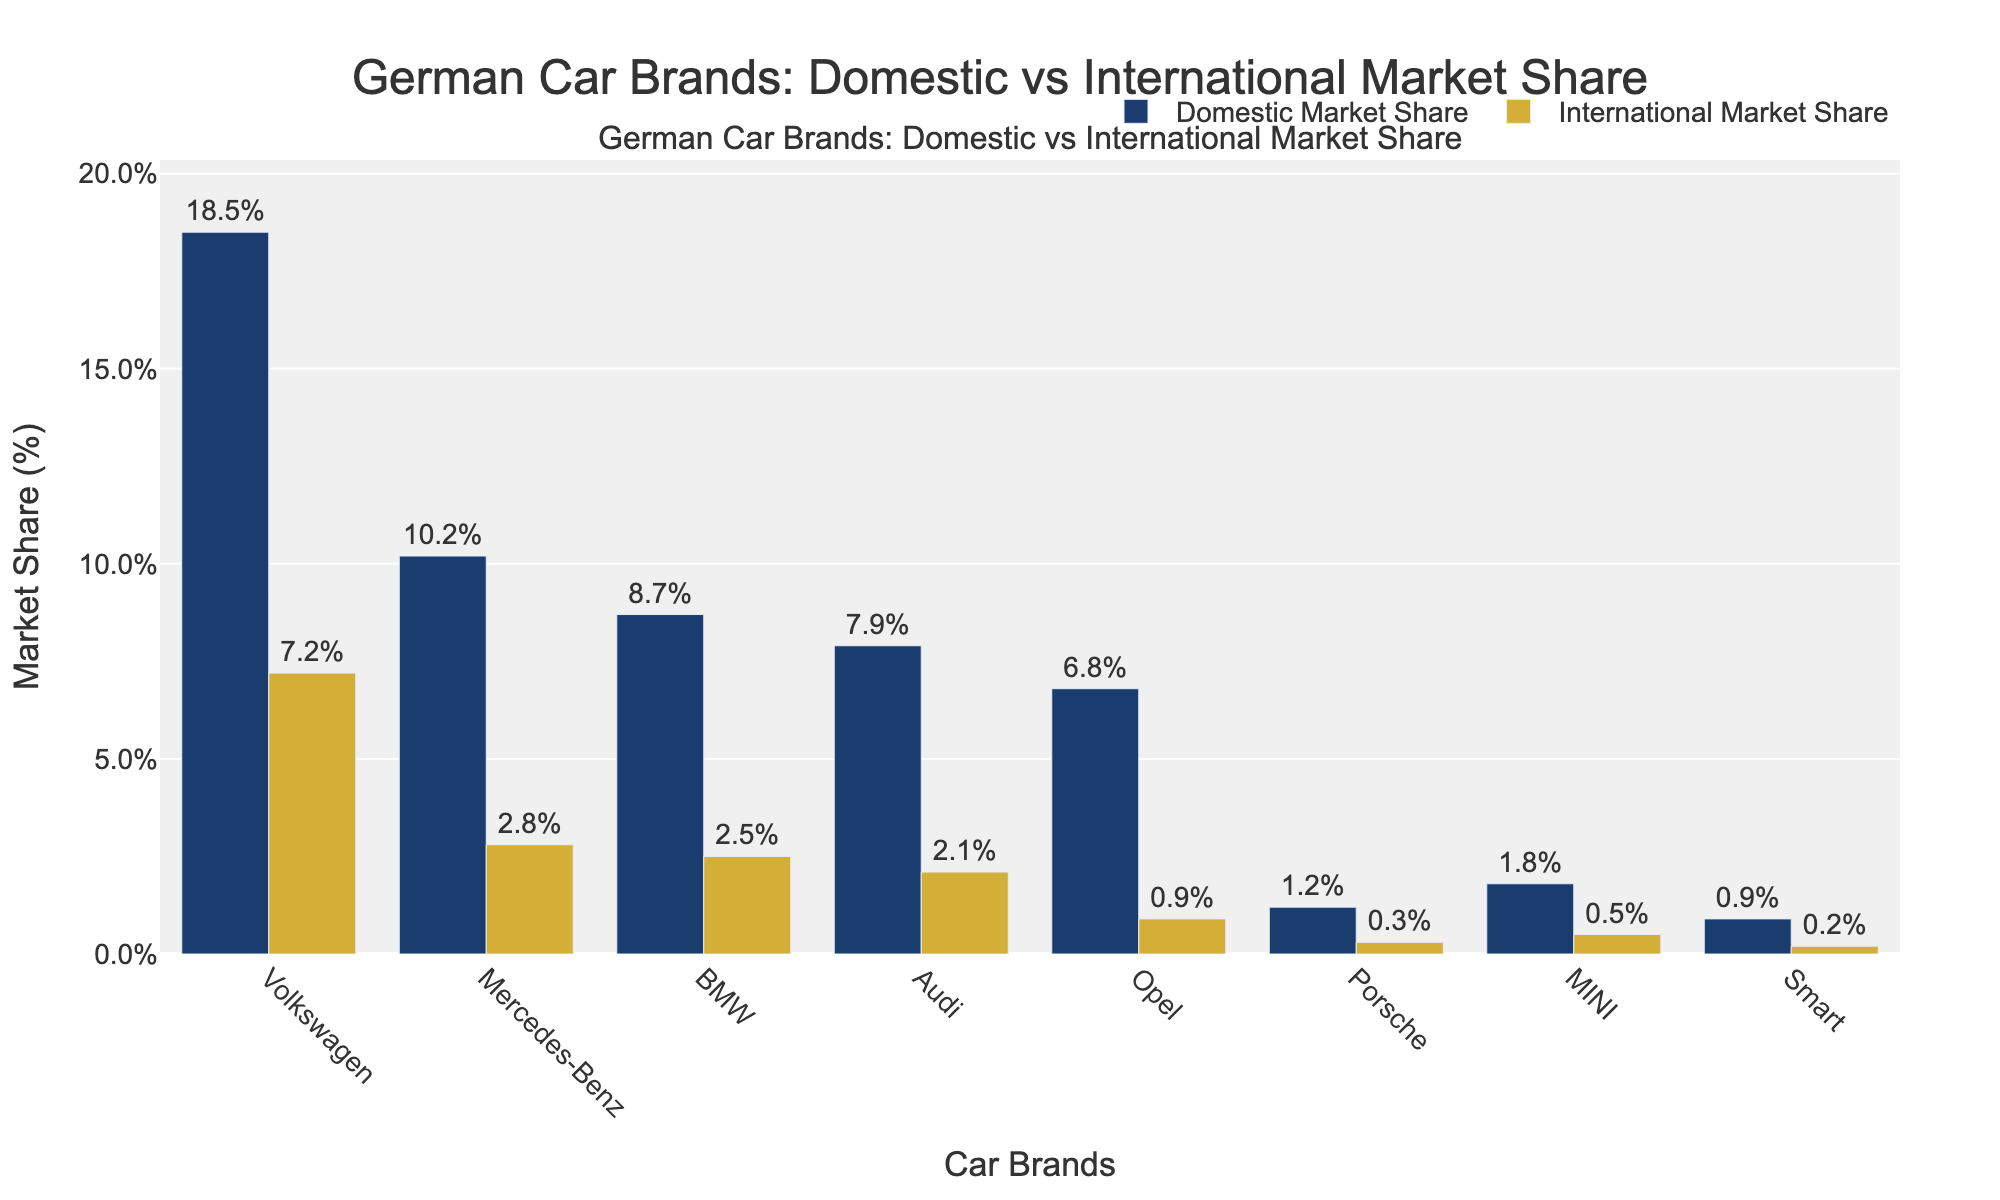Which brand has the highest domestic market share? Look at the heights of the bars representing the domestic market share. Volkswagen has the tallest bar, indicating the highest market share.
Answer: Volkswagen Which brand has a higher international market share, BMW or Audi? Compare the heights of the bars representing the international market shares for BMW and Audi. BMW has a bar reaching 2.5%, while Audi's bar is at 2.1%.
Answer: BMW What is the total market share of Mercedes-Benz domestically and internationally? Add the domestic market share (10.2%) and the international market share (2.8%) of Mercedes-Benz together. 10.2% + 2.8% = 13.0%.
Answer: 13.0% How much greater is Volkswagen's domestic market share compared to Opel's international market share? Subtract Opel's international market share (0.9%) from Volkswagen's domestic market share (18.5%). 18.5% - 0.9% = 17.6%.
Answer: 17.6% Which brand has the smallest difference between its domestic and international market shares? Calculate the difference for each brand and find the smallest. Smart has a difference of 0.7% (0.9% - 0.2%).
Answer: Smart How many brands have a domestic market share above 5%? Count the number of bars representing the domestic market share that exceed the 5% mark. There are five brands: Volkswagen, Mercedes-Benz, BMW, Audi, and Opel.
Answer: 5 Which brand has the least international market share? Identify the bar with the smallest height representing the international market share. Porsche has the shortest bar at 0.3%.
Answer: Porsche What is the average international market share of all the brands? Sum the international market shares of all brands and divide by the number of brands. (7.2% + 2.8% + 2.5% + 2.1% + 0.9% + 0.3% + 0.5% + 0.2%) / 8 = 16.5% / 8 = 2.06%.
Answer: 2.06% How much higher is the domestic market share of BMW compared to Smart? Subtract Smart's domestic market share (0.9%) from BMW's domestic market share (8.7%). 8.7% - 0.9% = 7.8%.
Answer: 7.8% What is the sum of market share percentages for Mercedes-Benz both domestically and internationally combined? Add the domestic market share (10.2%) and the international market share (2.8%) of Mercedes-Benz. 10.2% + 2.8% = 13.0%.
Answer: 13.0% 